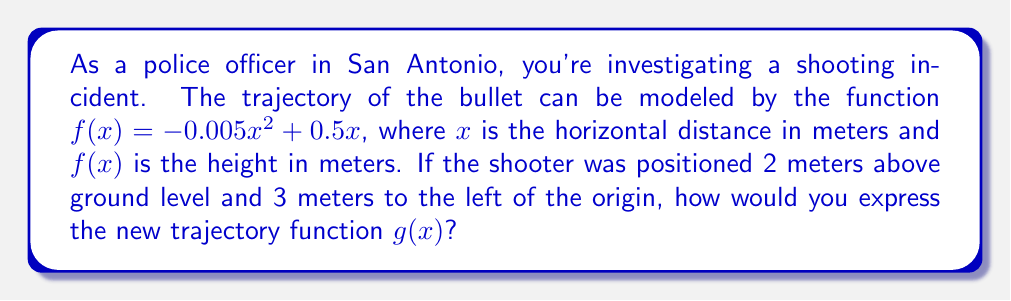Can you solve this math problem? To solve this problem, we need to apply function transformations to the original function $f(x)$. Let's break it down step-by-step:

1. The shooter is positioned 2 meters above ground level:
   This requires a vertical shift upward by 2 units.
   Transformation: $f(x) + 2$

2. The shooter is positioned 3 meters to the left of the origin:
   This requires a horizontal shift right by 3 units.
   Transformation: $f(x - 3)$

3. Combining these transformations:
   $g(x) = f(x - 3) + 2$

4. Substituting the original function:
   $g(x) = -0.005(x - 3)^2 + 0.5(x - 3) + 2$

5. Expanding the squared term:
   $g(x) = -0.005(x^2 - 6x + 9) + 0.5x - 1.5 + 2$

6. Simplifying:
   $g(x) = -0.005x^2 + 0.03x - 0.045 + 0.5x - 1.5 + 2$
   $g(x) = -0.005x^2 + 0.53x + 0.455$

Therefore, the new trajectory function $g(x)$ is $-0.005x^2 + 0.53x + 0.455$.
Answer: $g(x) = -0.005x^2 + 0.53x + 0.455$ 